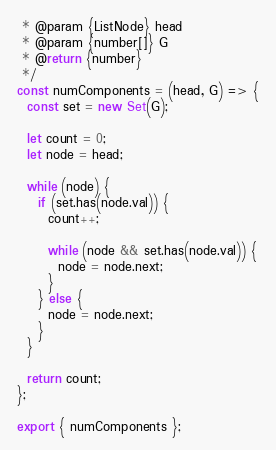Convert code to text. <code><loc_0><loc_0><loc_500><loc_500><_JavaScript_> * @param {ListNode} head
 * @param {number[]} G
 * @return {number}
 */
const numComponents = (head, G) => {
  const set = new Set(G);

  let count = 0;
  let node = head;

  while (node) {
    if (set.has(node.val)) {
      count++;

      while (node && set.has(node.val)) {
        node = node.next;
      }
    } else {
      node = node.next;
    }
  }

  return count;
};

export { numComponents };
</code> 